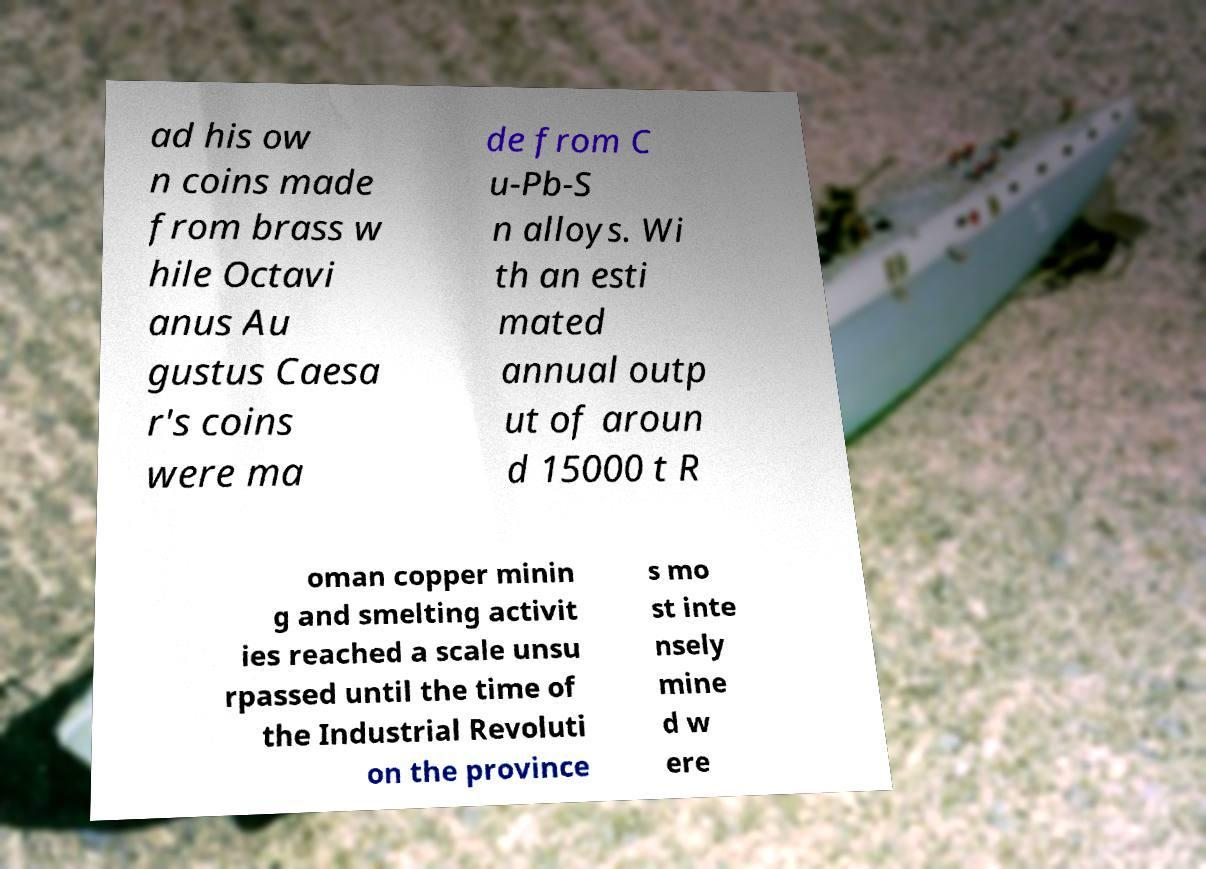Can you read and provide the text displayed in the image?This photo seems to have some interesting text. Can you extract and type it out for me? ad his ow n coins made from brass w hile Octavi anus Au gustus Caesa r's coins were ma de from C u-Pb-S n alloys. Wi th an esti mated annual outp ut of aroun d 15000 t R oman copper minin g and smelting activit ies reached a scale unsu rpassed until the time of the Industrial Revoluti on the province s mo st inte nsely mine d w ere 